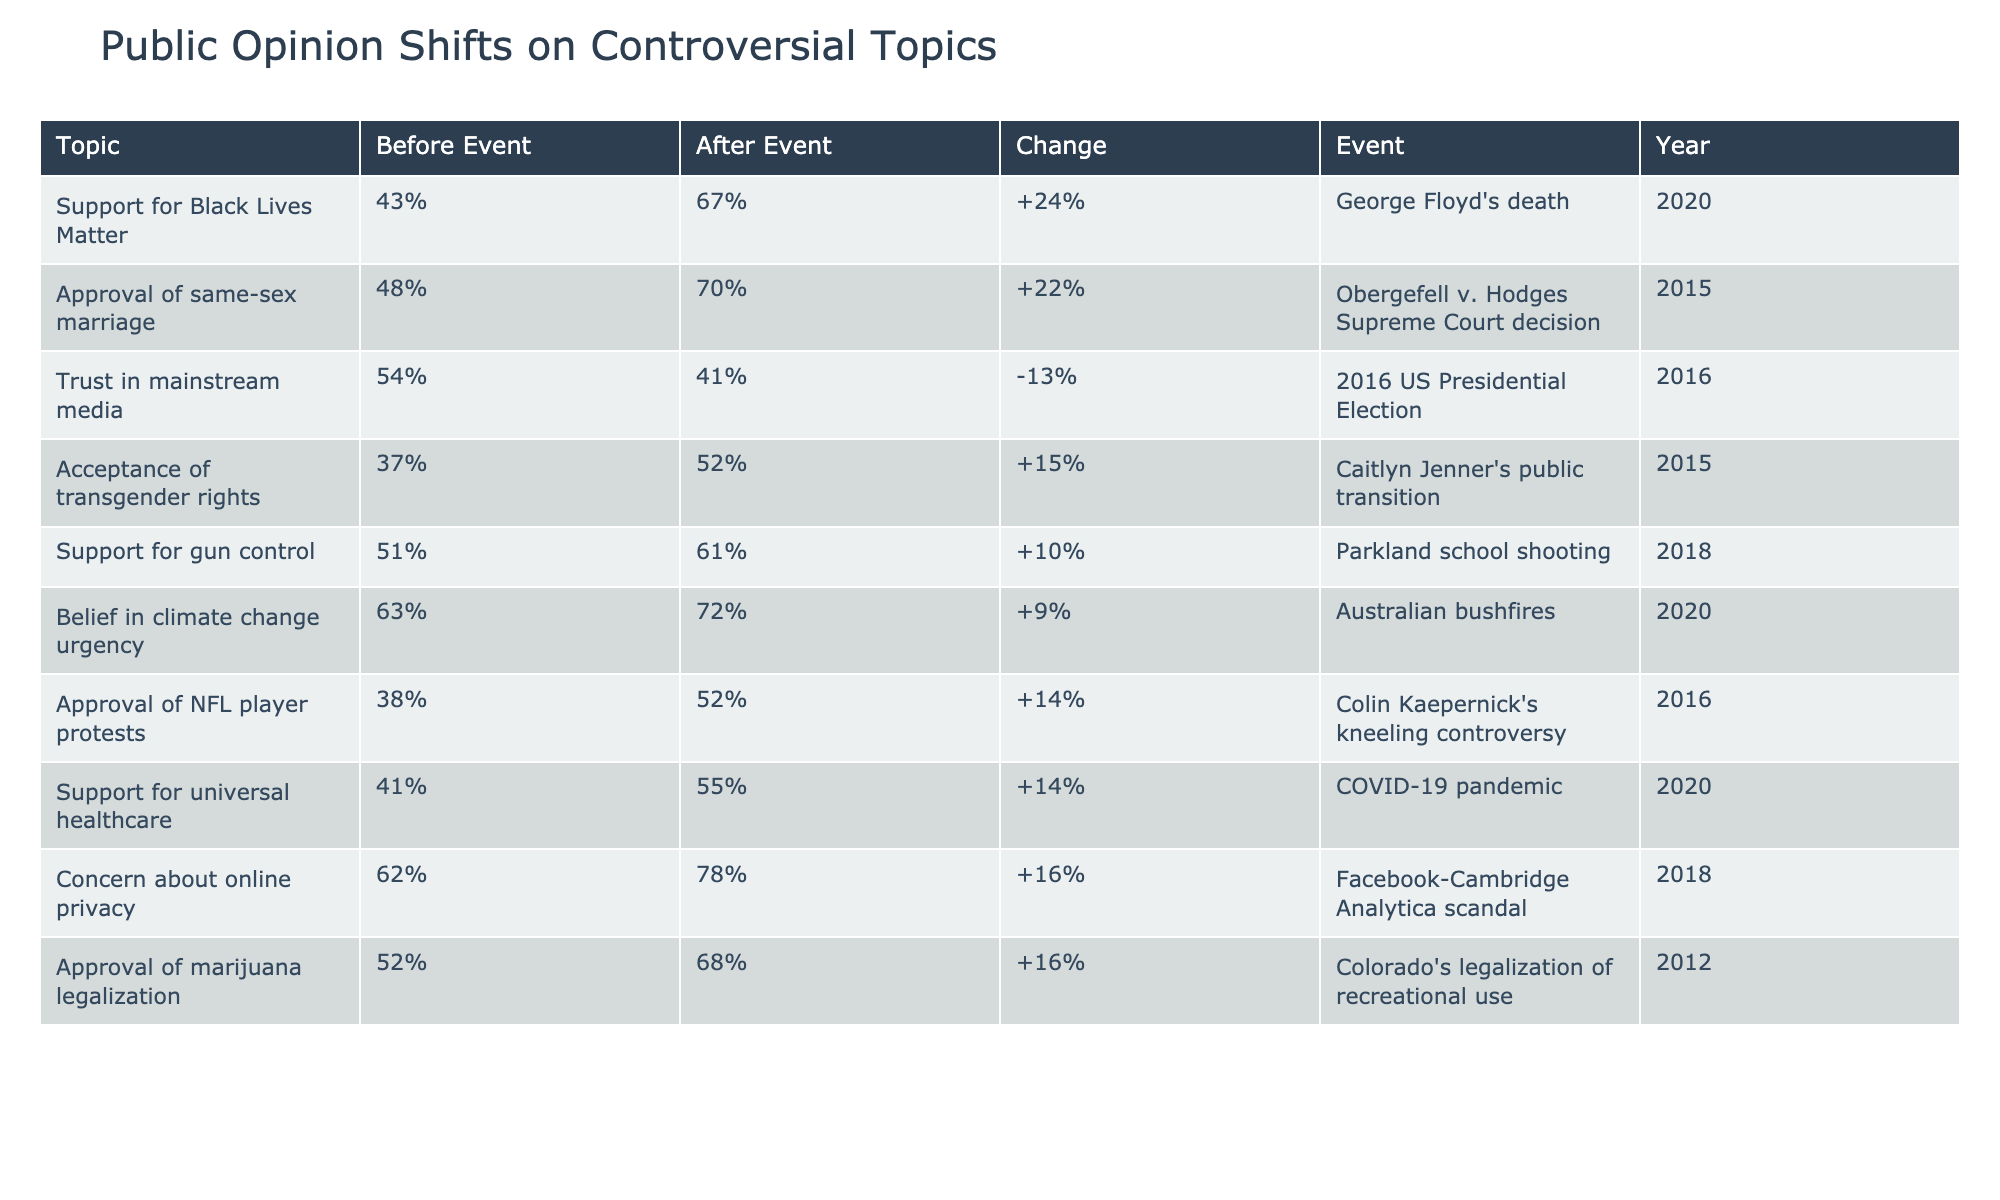What was the percentage increase in support for Black Lives Matter after George Floyd's death? The support increased from 43% to 67%. To find the percentage increase, subtract the before event percentage from the after event percentage: 67% - 43% = 24%.
Answer: 24% What was the percentage of approval for same-sex marriage before the Obergefell v. Hodges decision? The table shows that before the decision, the approval for same-sex marriage was 48%.
Answer: 48% Did trust in mainstream media increase after the 2016 US Presidential Election? The trust decreased from 54% to 41% after the election, indicating a decline in trust in mainstream media.
Answer: No Which topic had the highest percentage change in public opinion after the relevant event? By examining the changes in the table, the biggest increase is for concern about online privacy, which rose by 16 percentage points (from 62% to 78%).
Answer: Concern about online privacy What is the average percentage of approval for marijuana legalization and support for universal healthcare after their respective events? The approval for marijuana legalization after the event is 68%, and support for universal healthcare after COVID-19 is 55%. To find the average: (68% + 55%) / 2 = 61.5%.
Answer: 61.5% Was support for gun control higher after the Parkland school shooting? Yes, it increased from 51% to 61% after the shooting, indicating a rise in support for gun control.
Answer: Yes What were the acceptance percentages for transgender rights before and after Caitlyn Jenner's public transition? The acceptance for transgender rights increased from 37% before the transition to 52% after it.
Answer: 37% before, 52% after How many topics showed an increase of over 10 percentage points in public opinion after their events? By reviewing the table, the topics with increases over 10 percentage points include Black Lives Matter (24%), acceptance of transgender rights (15%), and concern about online privacy (16%). There are three such topics.
Answer: 3 What was the percentage change in belief in climate change urgency after the Australian bushfires? The belief rose from 63% to 72%. The percentage change is calculated as 72% - 63% = 9%.
Answer: 9% 